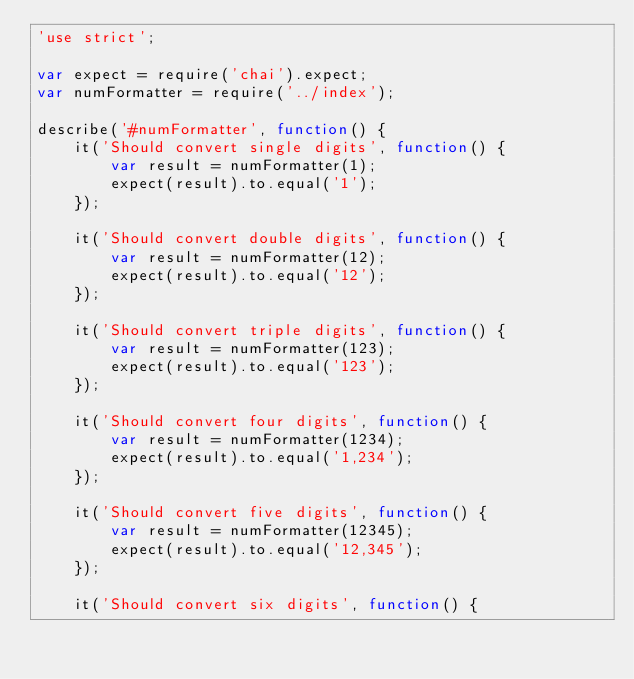<code> <loc_0><loc_0><loc_500><loc_500><_JavaScript_>'use strict';

var expect = require('chai').expect;
var numFormatter = require('../index');

describe('#numFormatter', function() {
    it('Should convert single digits', function() {
        var result = numFormatter(1);
        expect(result).to.equal('1');
    });

    it('Should convert double digits', function() {
        var result = numFormatter(12);
        expect(result).to.equal('12');
    });

    it('Should convert triple digits', function() {
        var result = numFormatter(123);
        expect(result).to.equal('123');
    });

    it('Should convert four digits', function() {
        var result = numFormatter(1234);
        expect(result).to.equal('1,234');
    });

    it('Should convert five digits', function() {
        var result = numFormatter(12345);
        expect(result).to.equal('12,345');
    });

    it('Should convert six digits', function() {</code> 